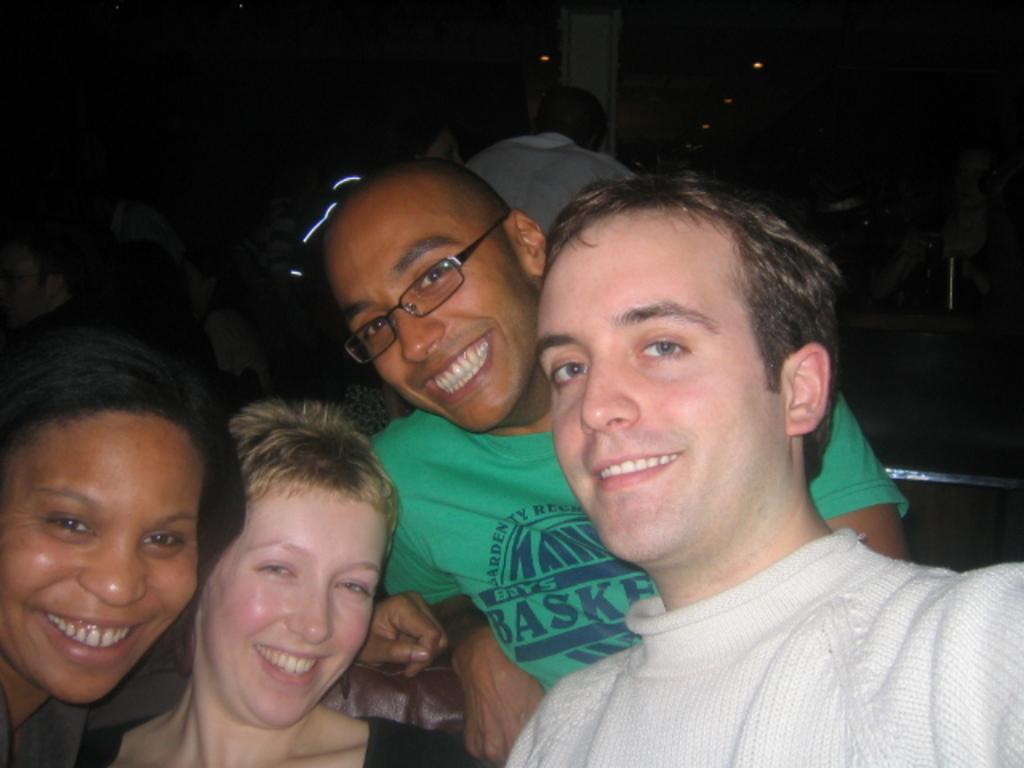Describe this image in one or two sentences. In this image I can see few persons smiling. One of the persons is wearing spectacles. In the background I can see few persons. The background is dark. 